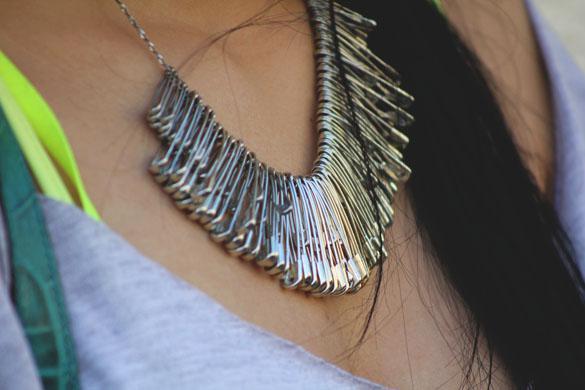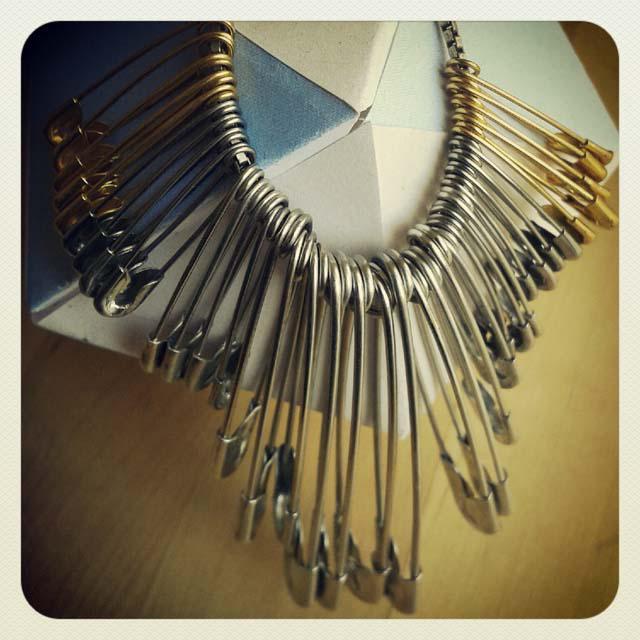The first image is the image on the left, the second image is the image on the right. Considering the images on both sides, is "The jewelry in the right photo is not made with any silver colored safety pins." valid? Answer yes or no. No. The first image is the image on the left, the second image is the image on the right. For the images shown, is this caption "An image features a necklace strung with only gold safety pins." true? Answer yes or no. No. 